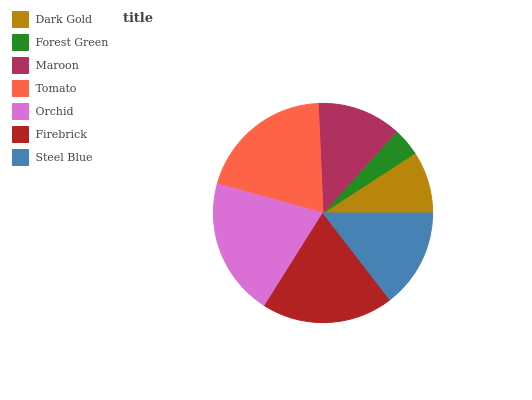Is Forest Green the minimum?
Answer yes or no. Yes. Is Orchid the maximum?
Answer yes or no. Yes. Is Maroon the minimum?
Answer yes or no. No. Is Maroon the maximum?
Answer yes or no. No. Is Maroon greater than Forest Green?
Answer yes or no. Yes. Is Forest Green less than Maroon?
Answer yes or no. Yes. Is Forest Green greater than Maroon?
Answer yes or no. No. Is Maroon less than Forest Green?
Answer yes or no. No. Is Steel Blue the high median?
Answer yes or no. Yes. Is Steel Blue the low median?
Answer yes or no. Yes. Is Firebrick the high median?
Answer yes or no. No. Is Maroon the low median?
Answer yes or no. No. 